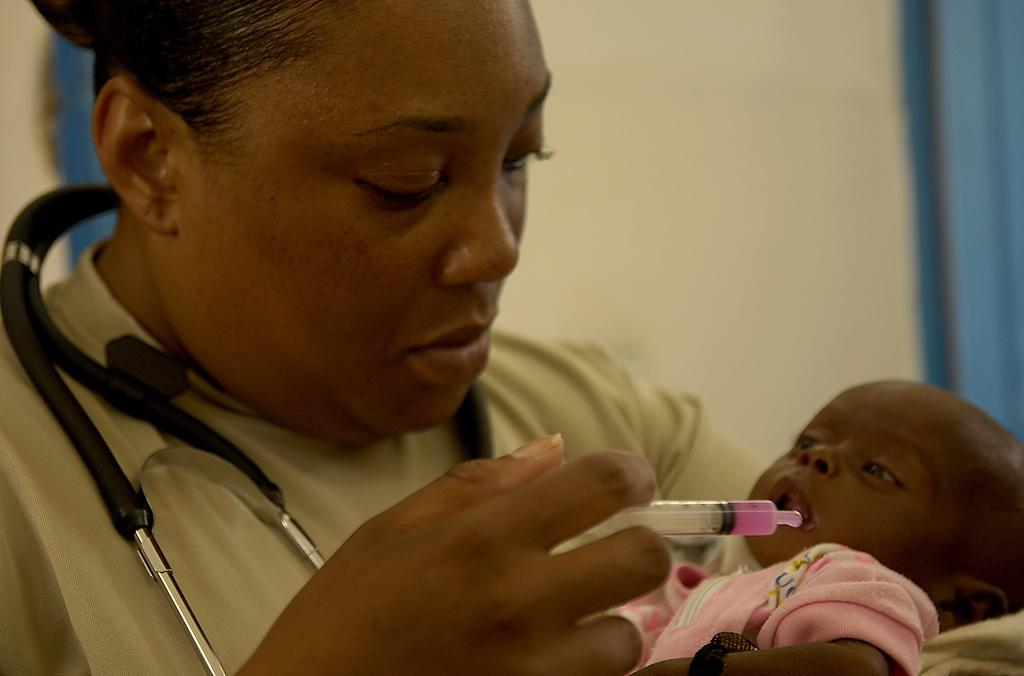What is the person in the image doing? The person with a stethoscope is holding a baby. How is the baby being fed in the image? The baby is being fed with a syringe. What can be seen in the background of the image? There is a wall in the background of the image. What type of jam is being spread on the skate in the image? There is no skate or jam present in the image. 